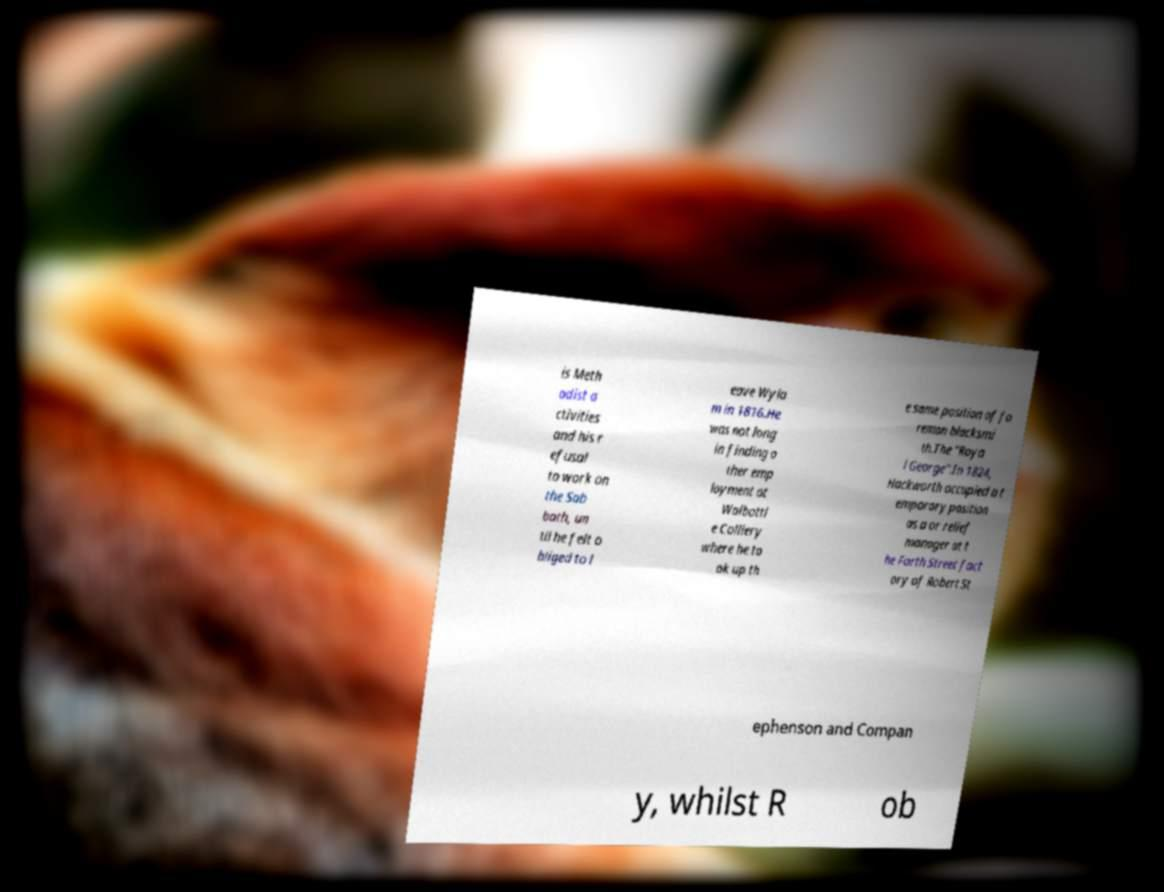Could you extract and type out the text from this image? is Meth odist a ctivities and his r efusal to work on the Sab bath, un til he felt o bliged to l eave Wyla m in 1816.He was not long in finding o ther emp loyment at Walbottl e Colliery where he to ok up th e same position of fo reman blacksmi th.The "Roya l George".In 1824, Hackworth occupied a t emporary position as a or relief manager at t he Forth Street fact ory of Robert St ephenson and Compan y, whilst R ob 